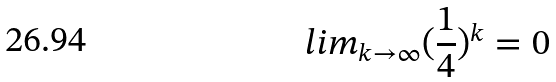Convert formula to latex. <formula><loc_0><loc_0><loc_500><loc_500>l i m _ { k \rightarrow \infty } ( \frac { 1 } { 4 } ) ^ { k } = 0</formula> 